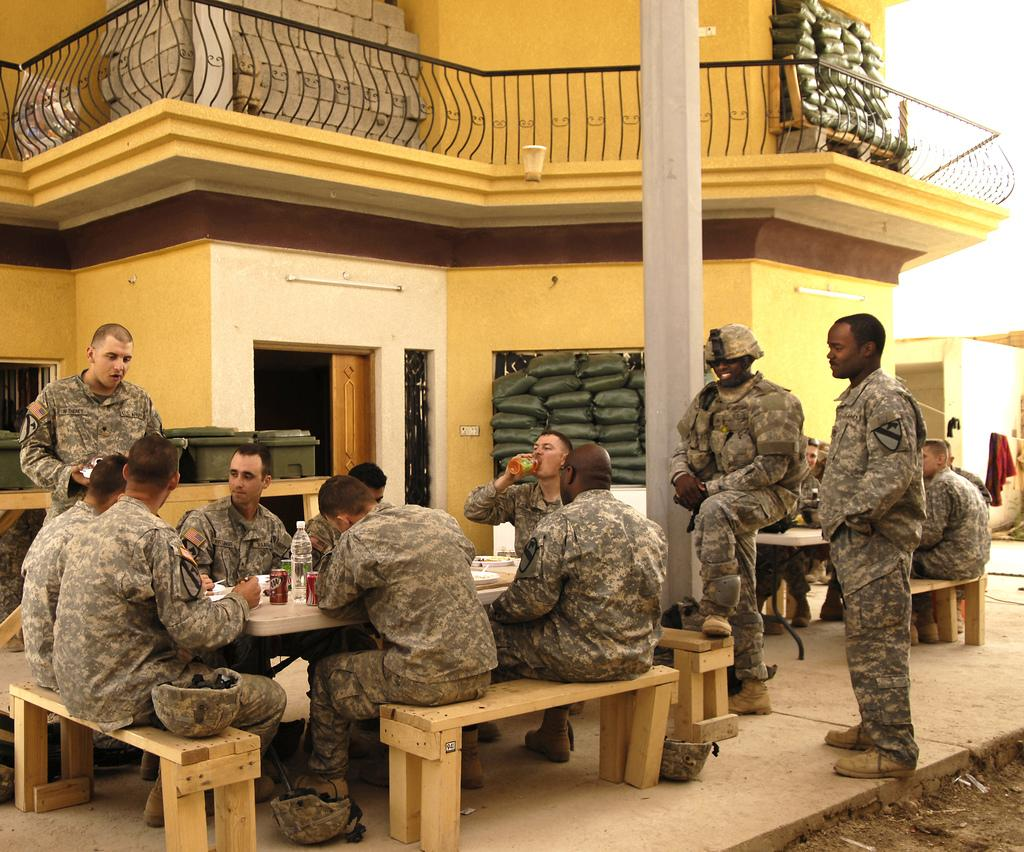What type of people can be seen in the image? There are army people in the image. What are the army people doing in the image? Some army people are sitting, while others are standing. What items are visible in the image that might be used for hydration? There are water bottles in the image. What type of structure is present in the image? There is a building in the image. What other object can be seen in the image? There is a pole in the image. What type of advice does the manager give to the army people in the image? There is no manager present in the image, so no advice can be given. What hobbies do the army people in the image enjoy during their free time? The image does not provide information about the army people's hobbies or free time activities. 